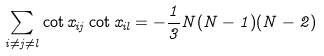<formula> <loc_0><loc_0><loc_500><loc_500>\sum _ { i \neq j \neq l } \cot x _ { i j } \cot x _ { i l } = - \frac { 1 } { 3 } N ( N - 1 ) ( N - 2 )</formula> 